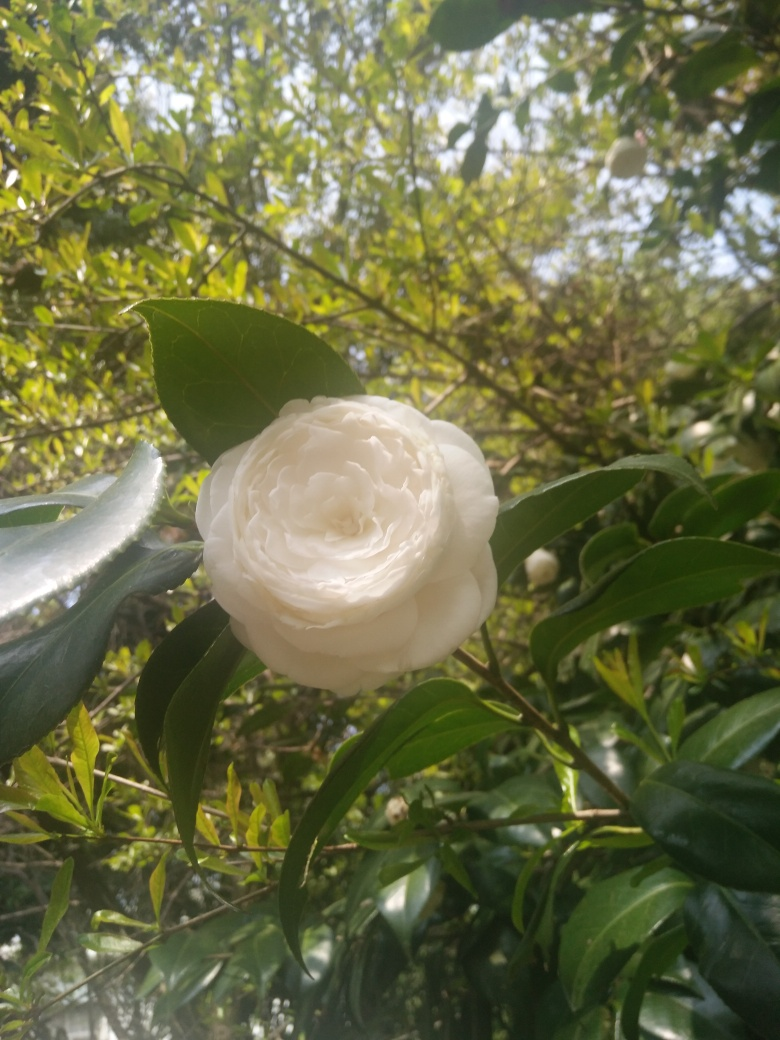Are there any distracting elements in the image? The image is quite focused with the white flower being the central element. The background is a little busy with leaves and branches, but it does not significantly detract from the main subject, the flower. However, the left edge of the frame has a bit of an overexposed section which could be slightly distracting. 